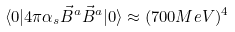<formula> <loc_0><loc_0><loc_500><loc_500>\langle 0 | 4 \pi \alpha _ { s } \vec { B } ^ { a } \vec { B } ^ { a } | 0 \rangle \approx ( 7 0 0 M e V ) ^ { 4 }</formula> 